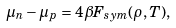Convert formula to latex. <formula><loc_0><loc_0><loc_500><loc_500>\mu _ { n } - \mu _ { p } = 4 \beta F _ { s y m } ( \rho , T ) ,</formula> 